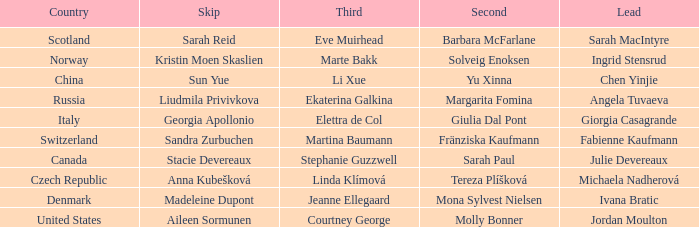What is the second that has jordan moulton as the lead? Molly Bonner. 